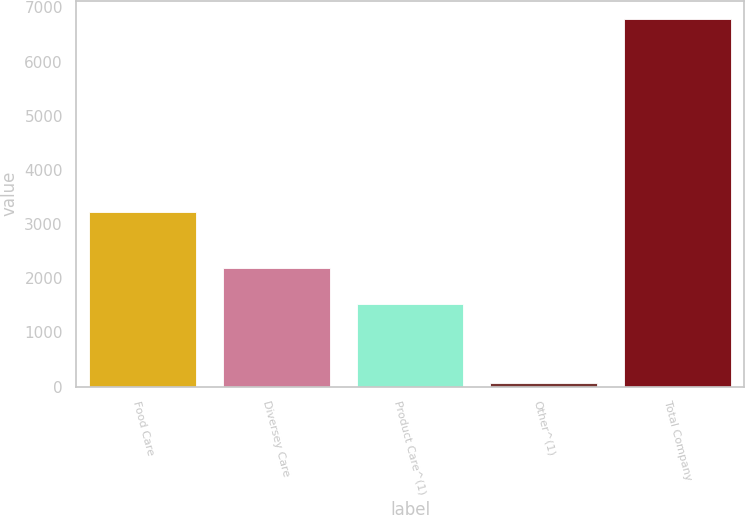Convert chart to OTSL. <chart><loc_0><loc_0><loc_500><loc_500><bar_chart><fcel>Food Care<fcel>Diversey Care<fcel>Product Care^(1)<fcel>Other^(1)<fcel>Total Company<nl><fcel>3222.1<fcel>2194.6<fcel>1523.7<fcel>69.3<fcel>6778.3<nl></chart> 